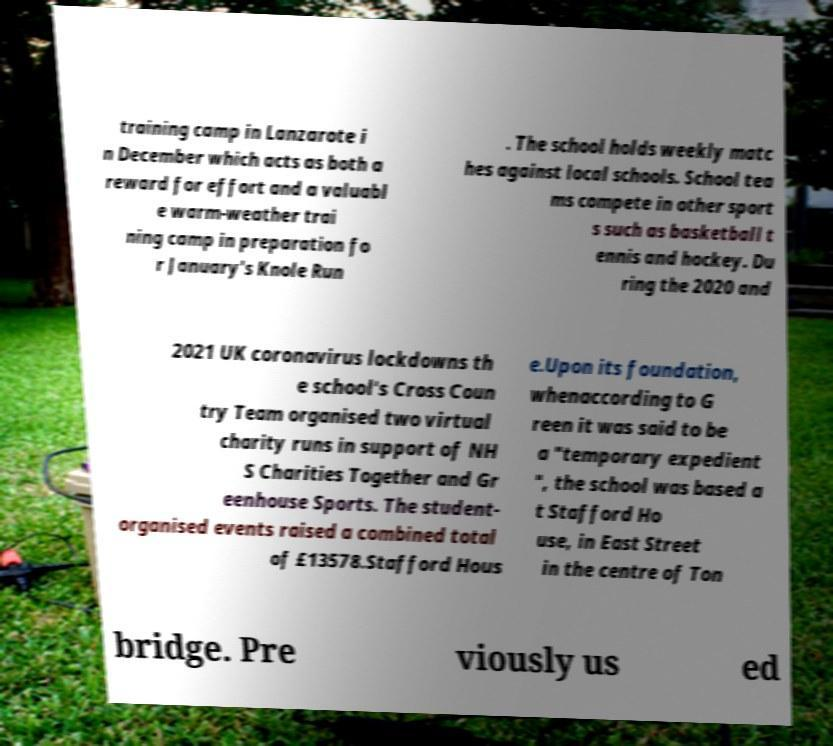Could you extract and type out the text from this image? training camp in Lanzarote i n December which acts as both a reward for effort and a valuabl e warm-weather trai ning camp in preparation fo r January's Knole Run . The school holds weekly matc hes against local schools. School tea ms compete in other sport s such as basketball t ennis and hockey. Du ring the 2020 and 2021 UK coronavirus lockdowns th e school's Cross Coun try Team organised two virtual charity runs in support of NH S Charities Together and Gr eenhouse Sports. The student- organised events raised a combined total of £13578.Stafford Hous e.Upon its foundation, whenaccording to G reen it was said to be a "temporary expedient ", the school was based a t Stafford Ho use, in East Street in the centre of Ton bridge. Pre viously us ed 